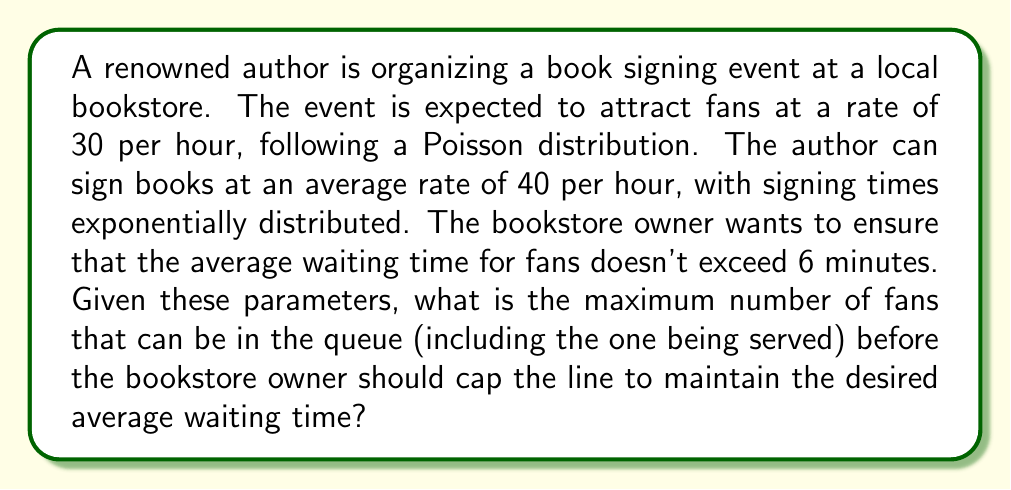Solve this math problem. To solve this problem, we'll use the M/M/1 queuing model, where arrivals follow a Poisson distribution and service times are exponentially distributed with a single server (the author).

Let's define our variables:
$\lambda$ = arrival rate = 30 fans/hour
$\mu$ = service rate = 40 fans/hour
$W_q$ = average waiting time in queue = 6 minutes = 0.1 hours

Step 1: Calculate the utilization factor $\rho$
$$\rho = \frac{\lambda}{\mu} = \frac{30}{40} = 0.75$$

Step 2: Calculate the average number of fans in the system ($L$)
Using Little's Law and the formula for average number in an M/M/1 system:
$$L = \frac{\rho}{1-\rho} = \frac{0.75}{1-0.75} = 3$$

Step 3: Calculate the average waiting time in the system ($W$)
$$W = \frac{L}{\lambda} = \frac{3}{30} = 0.1 \text{ hours} = 6 \text{ minutes}$$

Step 4: Calculate the average number of fans in the queue ($L_q$)
$$L_q = L - \rho = 3 - 0.75 = 2.25$$

Step 5: Verify the average waiting time in the queue ($W_q$)
$$W_q = \frac{L_q}{\lambda} = \frac{2.25}{30} = 0.075 \text{ hours} = 4.5 \text{ minutes}$$

This is less than the desired 6 minutes, so we can allow more fans in the queue.

Step 6: Calculate the maximum number of fans allowed in the system
We use the formula for the probability of having exactly $n$ customers in an M/M/1 system:
$$P_n = (1-\rho)\rho^n$$

We want to find the largest $n$ such that the average waiting time doesn't exceed 6 minutes. We can use the formula:
$$W_q = \frac{n-1}{2\mu}$$

Solving for $n$:
$$6 = \frac{n-1}{2(40)}$$
$$n = 2(40)(0.1) + 1 = 9$$

Therefore, the maximum number of fans allowed in the system (including the one being served) should be 9.
Answer: The maximum number of fans that can be in the queue, including the one being served, before the bookstore owner should cap the line is 9. 